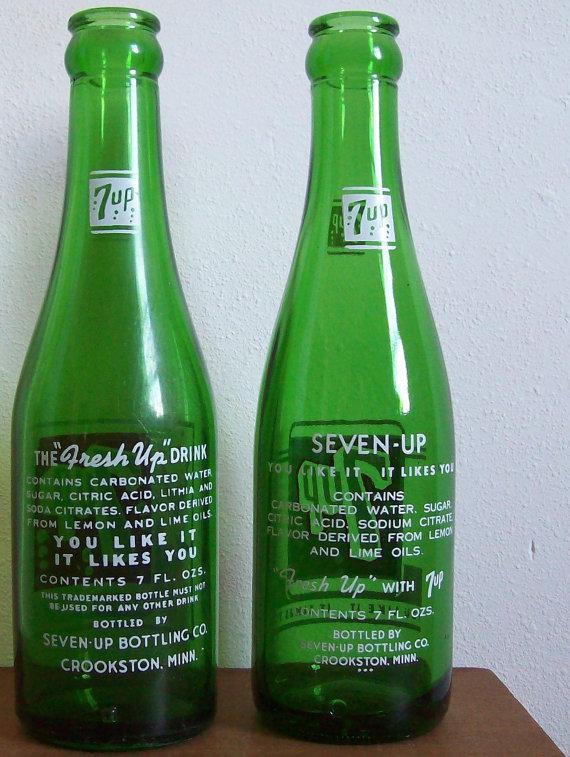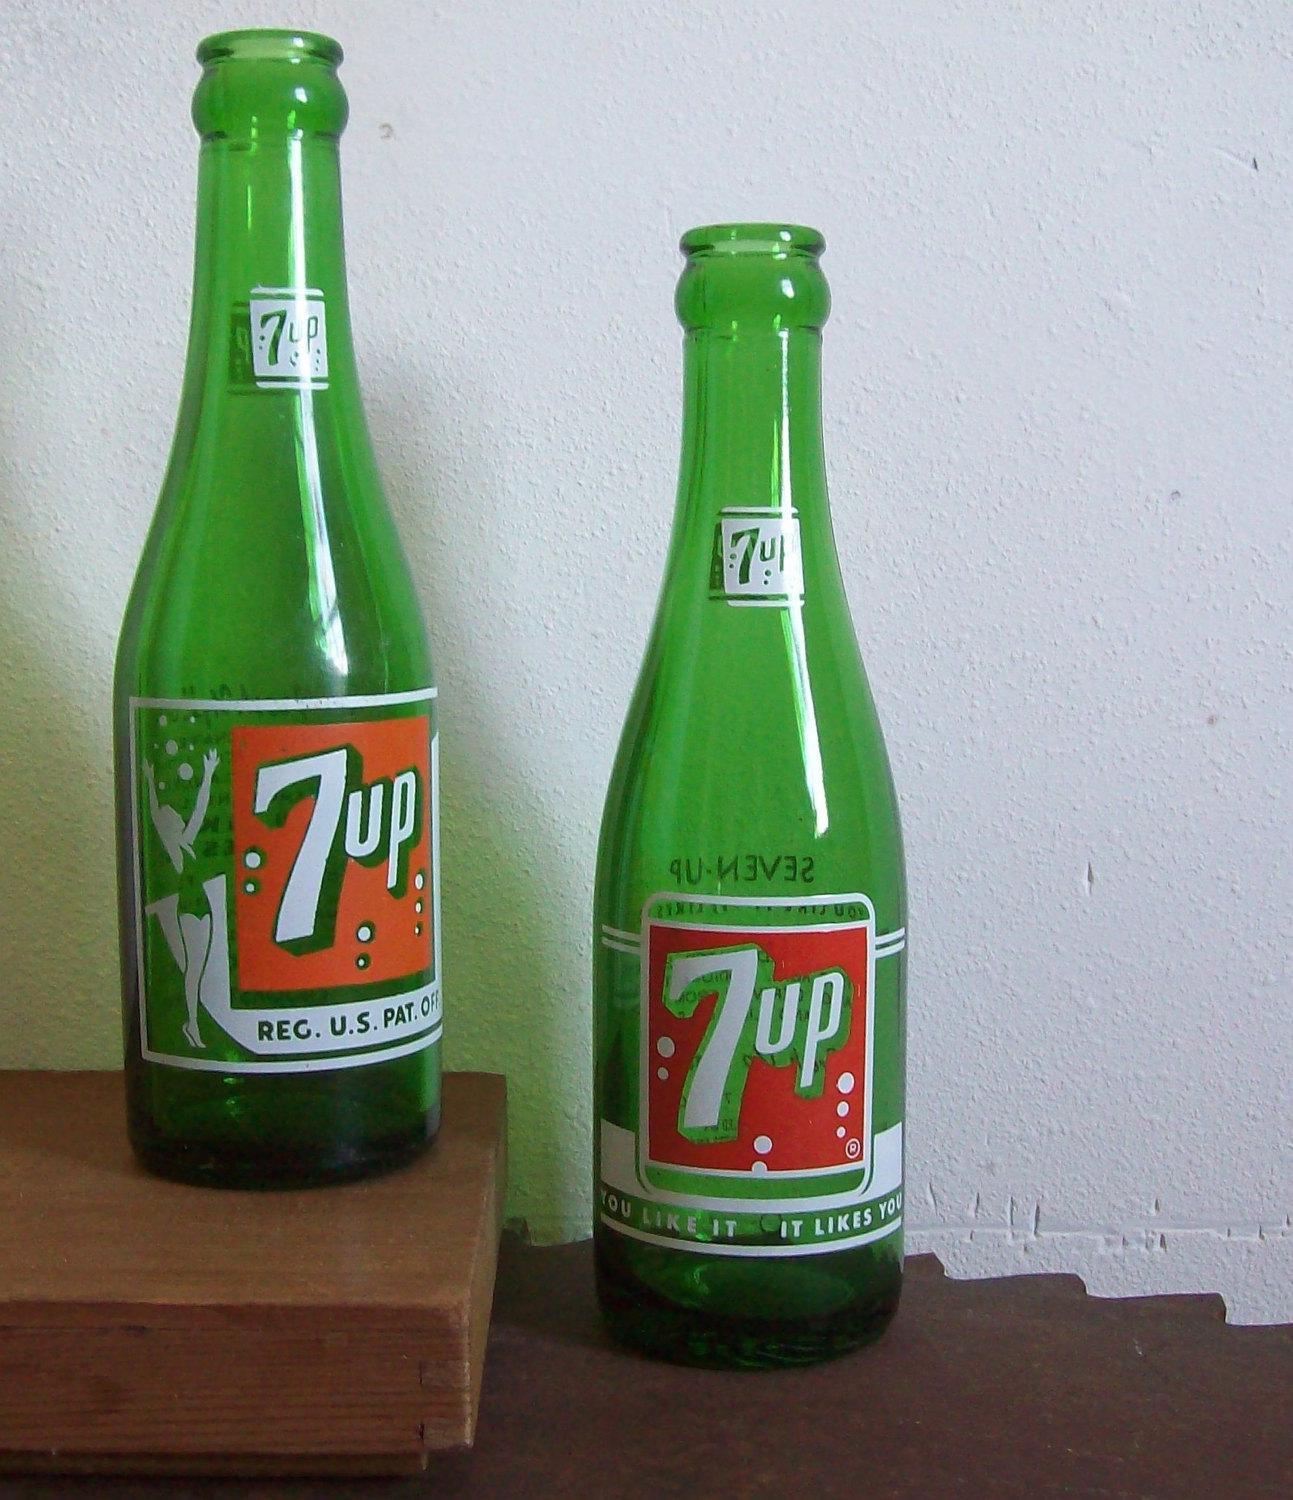The first image is the image on the left, the second image is the image on the right. Assess this claim about the two images: "None of the bottles are capped.". Correct or not? Answer yes or no. Yes. The first image is the image on the left, the second image is the image on the right. Analyze the images presented: Is the assertion "An equal number of soda bottles are in each image, all the same brand, but with different labeling in view." valid? Answer yes or no. Yes. 